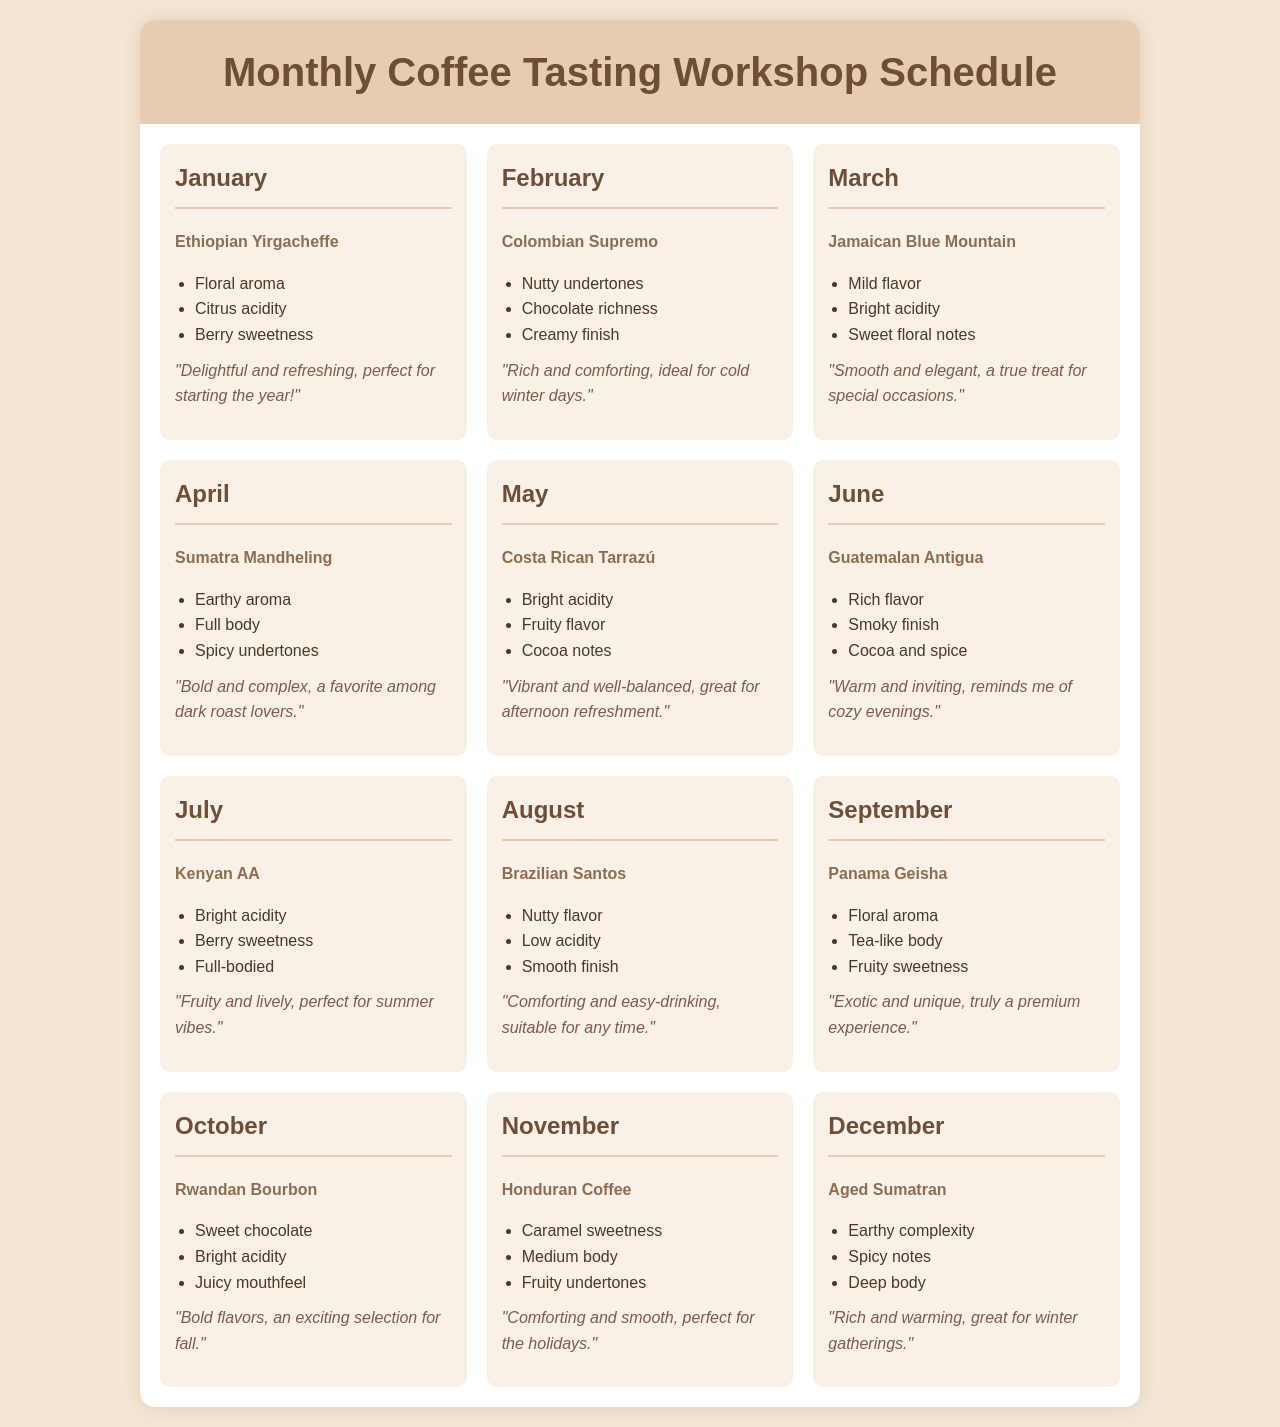What coffee type is explored in January? The coffee type for January listed in the document is Ethiopian Yirgacheffe.
Answer: Ethiopian Yirgacheffe What flavor notes are associated with Colombian Supremo? The document mentions nutty undertones, chocolate richness, and creamy finish for Colombian Supremo.
Answer: Nutty undertones, chocolate richness, creamy finish Which month features the coffee type Kenyan AA? The month that features Kenyan AA is July, according to the schedule.
Answer: July How many coffee types are listed in total? There are twelve distinct coffee types mentioned in the monthly schedule, one for each month of the year.
Answer: Twelve What is the participant feedback for the coffee type Panama Geisha? The feedback provided for Panama Geisha describes it as exotic and unique, indicating a premium experience.
Answer: Exotic and unique, truly a premium experience Which coffee type is characterized by earthy complexity? The document identifies Aged Sumatran as the coffee type with earthy complexity.
Answer: Aged Sumatran What is a common theme in the feedback for the coffee types in December? Feedback for coffee types in December generally conveys warmth and comfort, aligning with winter gatherings.
Answer: Comforting and smooth, perfect for the holidays Which coffee type has a bright acidity and berry sweetness? Kenyan AA is noted for its bright acidity and berry sweetness in the document.
Answer: Kenyan AA What is the coffee type for November? The coffee type explored in November is Honduran Coffee.
Answer: Honduran Coffee 